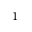<formula> <loc_0><loc_0><loc_500><loc_500>{ } ^ { 1 }</formula> 